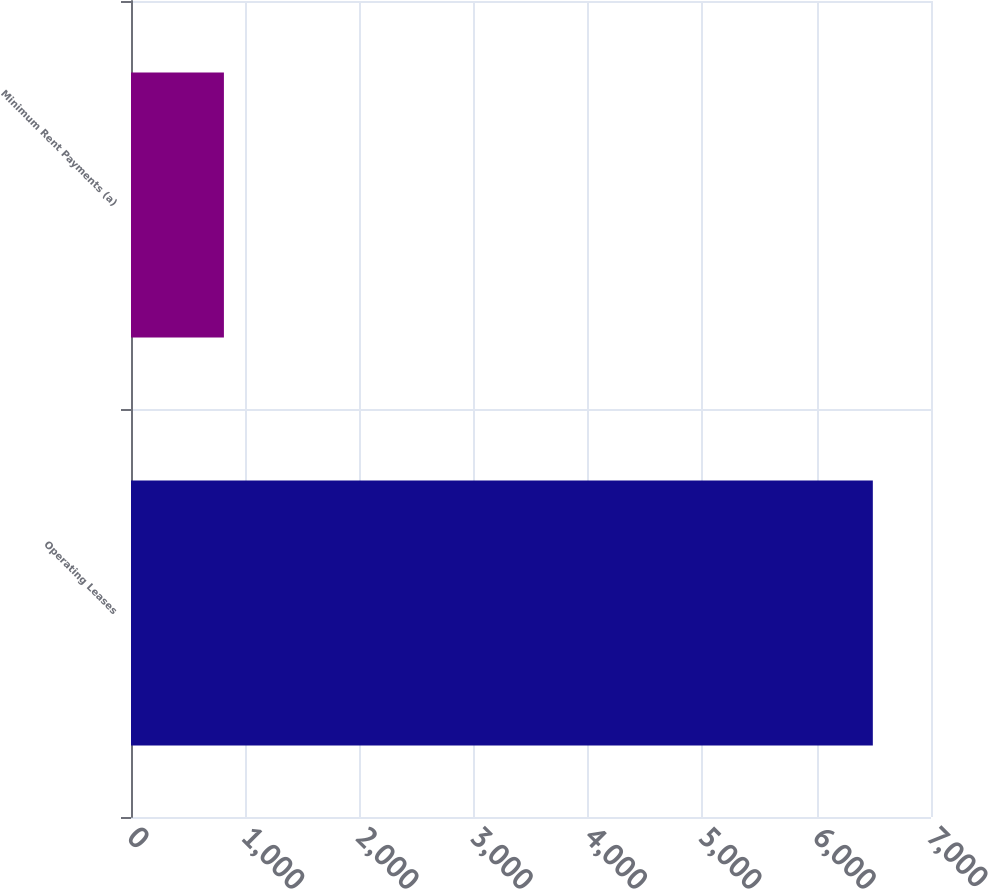<chart> <loc_0><loc_0><loc_500><loc_500><bar_chart><fcel>Operating Leases<fcel>Minimum Rent Payments (a)<nl><fcel>6491<fcel>813<nl></chart> 